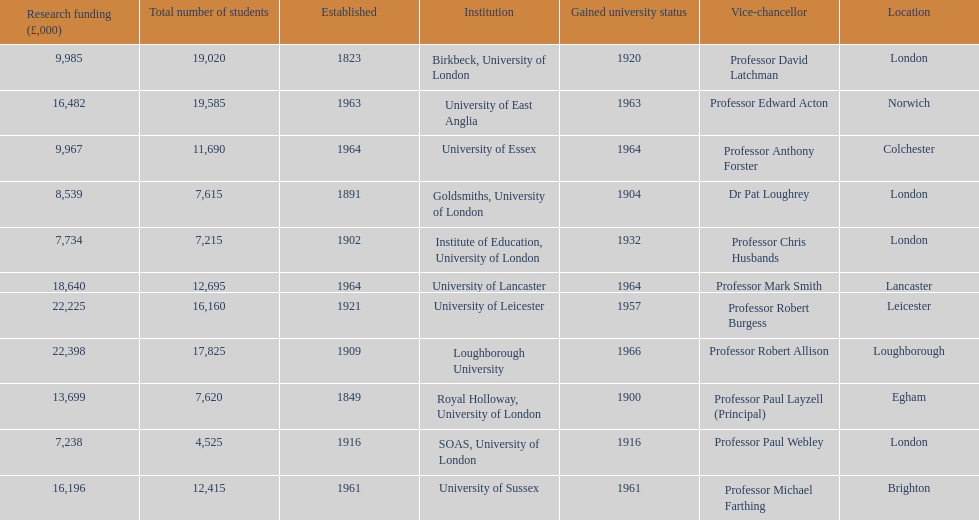How many of the institutions are located in london? 4. 